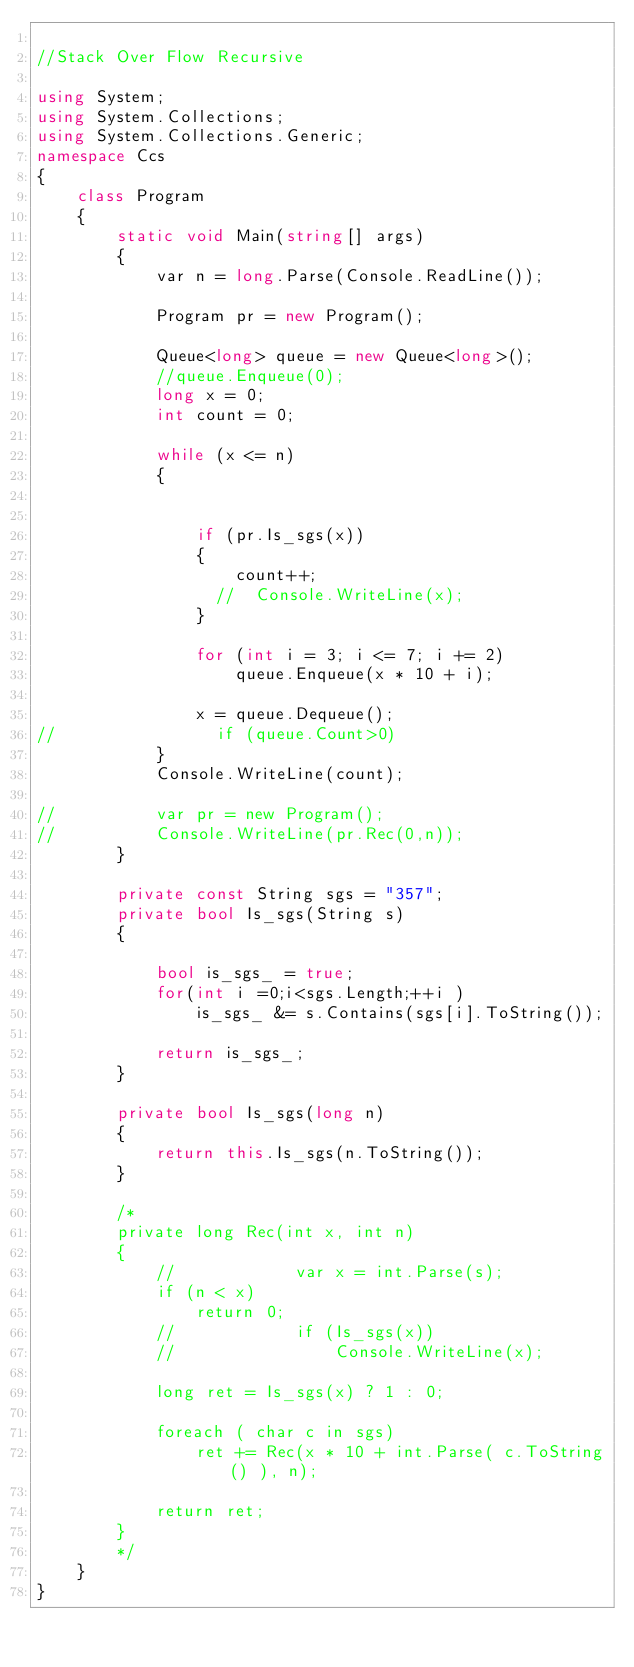<code> <loc_0><loc_0><loc_500><loc_500><_C#_>
//Stack Over Flow Recursive

using System;
using System.Collections;
using System.Collections.Generic;
namespace Ccs
{
    class Program
    {
        static void Main(string[] args)
        {
            var n = long.Parse(Console.ReadLine());

            Program pr = new Program();

            Queue<long> queue = new Queue<long>();
            //queue.Enqueue(0);
            long x = 0;
            int count = 0;

            while (x <= n)
            {

                
                if (pr.Is_sgs(x))
                {
                    count++;
                  //  Console.WriteLine(x);
                }

                for (int i = 3; i <= 7; i += 2)
                    queue.Enqueue(x * 10 + i);

                x = queue.Dequeue();
//                if (queue.Count>0)
            }
            Console.WriteLine(count);

//          var pr = new Program();
//          Console.WriteLine(pr.Rec(0,n));
        }

        private const String sgs = "357";
        private bool Is_sgs(String s)
        {
           
            bool is_sgs_ = true;
            for(int i =0;i<sgs.Length;++i )
                is_sgs_ &= s.Contains(sgs[i].ToString());
           
            return is_sgs_;
        }   
        
        private bool Is_sgs(long n)
        {
            return this.Is_sgs(n.ToString());
        }

        /*
        private long Rec(int x, int n)
        {
            //            var x = int.Parse(s);
            if (n < x)
                return 0;
            //            if (Is_sgs(x))
            //                Console.WriteLine(x);

            long ret = Is_sgs(x) ? 1 : 0;

            foreach ( char c in sgs)
                ret += Rec(x * 10 + int.Parse( c.ToString() ), n);

            return ret;
        }
        */
    }
}
</code> 